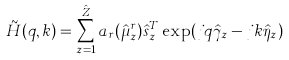Convert formula to latex. <formula><loc_0><loc_0><loc_500><loc_500>\tilde { H } ( q , k ) = \sum _ { z = 1 } ^ { \hat { Z } } a _ { r } ( \hat { \mu } ^ { r } _ { z } ) \hat { s } ^ { T } _ { z } \exp ( j q \hat { \gamma } _ { z } - j k \hat { \eta } _ { z } )</formula> 